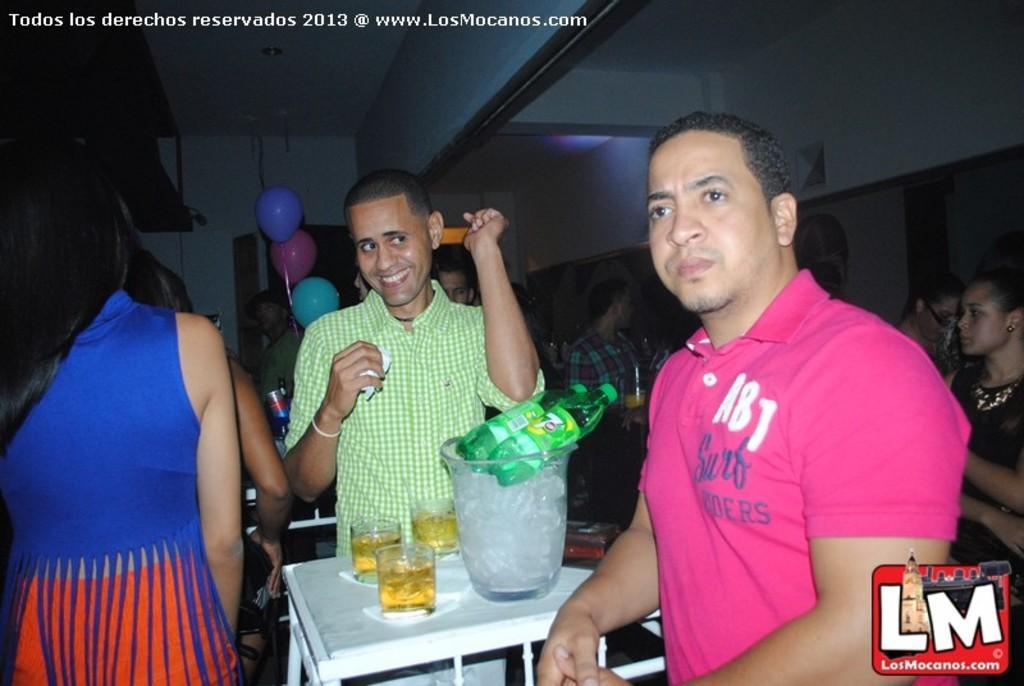Describe this image in one or two sentences. In this image I can see the group of people with different color dresses. I can see the table in-between these people. On the table I can see the glasses, bottles and ice basket. In the background I can see the colorful balloons and the wall. 